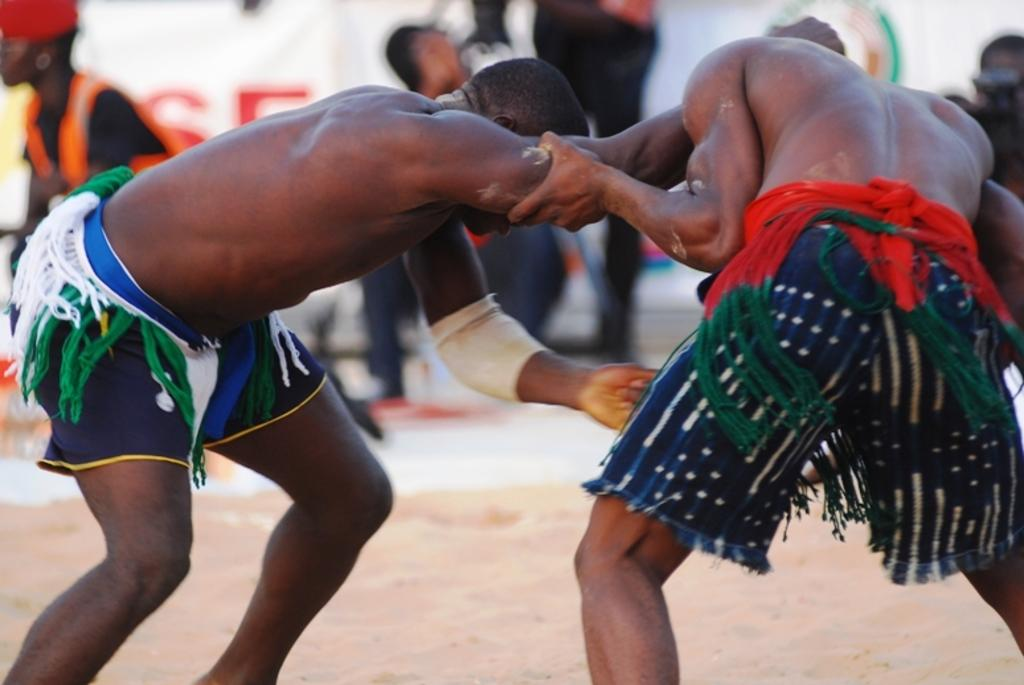What are the two persons in the image doing? The two persons in the image are standing and fighting. What can be seen in the background of the image? There is a group of people at the back of the image. What is the surface on which the persons are standing? There is sand at the bottom of the image. What type of pies are being thrown by the persons in the image? There are no pies present in the image; the two persons are fighting, not throwing pies. 